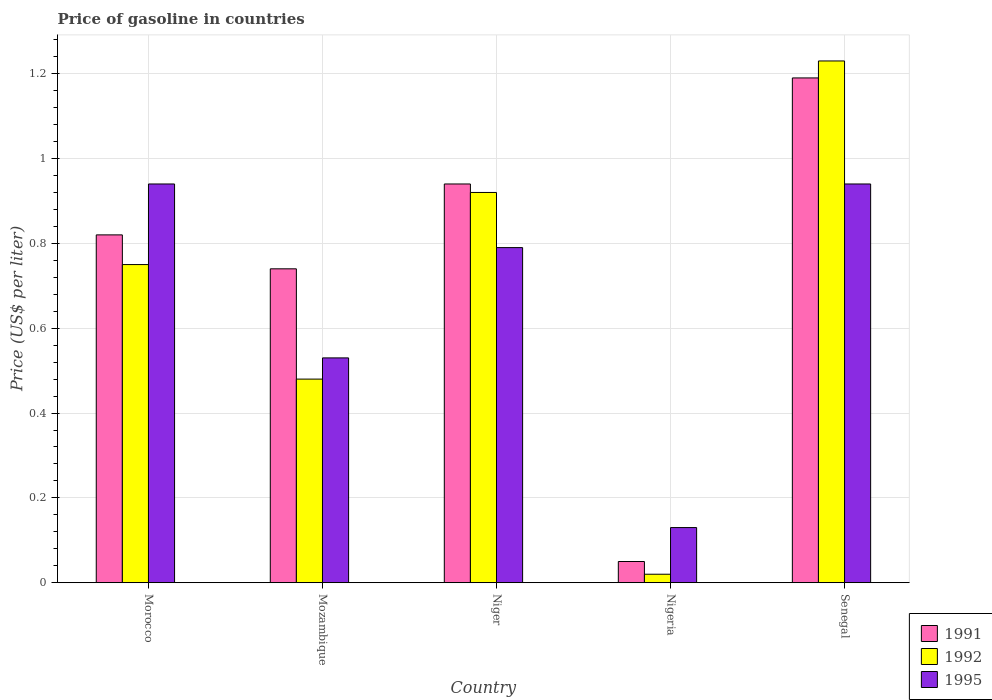How many groups of bars are there?
Offer a very short reply. 5. Are the number of bars on each tick of the X-axis equal?
Ensure brevity in your answer.  Yes. How many bars are there on the 1st tick from the left?
Offer a terse response. 3. What is the label of the 3rd group of bars from the left?
Your answer should be very brief. Niger. What is the price of gasoline in 1992 in Morocco?
Keep it short and to the point. 0.75. Across all countries, what is the maximum price of gasoline in 1995?
Provide a succinct answer. 0.94. Across all countries, what is the minimum price of gasoline in 1995?
Offer a terse response. 0.13. In which country was the price of gasoline in 1991 maximum?
Provide a succinct answer. Senegal. In which country was the price of gasoline in 1992 minimum?
Provide a short and direct response. Nigeria. What is the total price of gasoline in 1991 in the graph?
Give a very brief answer. 3.74. What is the difference between the price of gasoline in 1991 in Niger and the price of gasoline in 1995 in Mozambique?
Ensure brevity in your answer.  0.41. What is the average price of gasoline in 1995 per country?
Make the answer very short. 0.67. What is the difference between the price of gasoline of/in 1992 and price of gasoline of/in 1995 in Senegal?
Your answer should be very brief. 0.29. In how many countries, is the price of gasoline in 1991 greater than 0.12 US$?
Provide a short and direct response. 4. What is the ratio of the price of gasoline in 1995 in Niger to that in Nigeria?
Provide a succinct answer. 6.08. Is the price of gasoline in 1991 in Mozambique less than that in Senegal?
Give a very brief answer. Yes. What is the difference between the highest and the second highest price of gasoline in 1992?
Give a very brief answer. -0.31. What is the difference between the highest and the lowest price of gasoline in 1991?
Your answer should be very brief. 1.14. Is the sum of the price of gasoline in 1992 in Mozambique and Niger greater than the maximum price of gasoline in 1991 across all countries?
Your answer should be very brief. Yes. What does the 1st bar from the left in Mozambique represents?
Keep it short and to the point. 1991. What does the 3rd bar from the right in Niger represents?
Offer a terse response. 1991. Is it the case that in every country, the sum of the price of gasoline in 1991 and price of gasoline in 1995 is greater than the price of gasoline in 1992?
Keep it short and to the point. Yes. How many bars are there?
Your response must be concise. 15. Are all the bars in the graph horizontal?
Your answer should be very brief. No. How many countries are there in the graph?
Your response must be concise. 5. Does the graph contain any zero values?
Offer a very short reply. No. Does the graph contain grids?
Ensure brevity in your answer.  Yes. Where does the legend appear in the graph?
Your answer should be compact. Bottom right. How many legend labels are there?
Provide a succinct answer. 3. What is the title of the graph?
Offer a terse response. Price of gasoline in countries. Does "2012" appear as one of the legend labels in the graph?
Provide a short and direct response. No. What is the label or title of the Y-axis?
Make the answer very short. Price (US$ per liter). What is the Price (US$ per liter) of 1991 in Morocco?
Give a very brief answer. 0.82. What is the Price (US$ per liter) of 1991 in Mozambique?
Your response must be concise. 0.74. What is the Price (US$ per liter) in 1992 in Mozambique?
Make the answer very short. 0.48. What is the Price (US$ per liter) in 1995 in Mozambique?
Provide a short and direct response. 0.53. What is the Price (US$ per liter) of 1992 in Niger?
Provide a short and direct response. 0.92. What is the Price (US$ per liter) of 1995 in Niger?
Provide a short and direct response. 0.79. What is the Price (US$ per liter) of 1995 in Nigeria?
Provide a succinct answer. 0.13. What is the Price (US$ per liter) in 1991 in Senegal?
Provide a succinct answer. 1.19. What is the Price (US$ per liter) in 1992 in Senegal?
Offer a terse response. 1.23. What is the Price (US$ per liter) in 1995 in Senegal?
Your answer should be very brief. 0.94. Across all countries, what is the maximum Price (US$ per liter) of 1991?
Your answer should be compact. 1.19. Across all countries, what is the maximum Price (US$ per liter) in 1992?
Give a very brief answer. 1.23. Across all countries, what is the maximum Price (US$ per liter) of 1995?
Your answer should be compact. 0.94. Across all countries, what is the minimum Price (US$ per liter) in 1995?
Your answer should be compact. 0.13. What is the total Price (US$ per liter) in 1991 in the graph?
Your answer should be compact. 3.74. What is the total Price (US$ per liter) in 1992 in the graph?
Offer a terse response. 3.4. What is the total Price (US$ per liter) of 1995 in the graph?
Make the answer very short. 3.33. What is the difference between the Price (US$ per liter) in 1992 in Morocco and that in Mozambique?
Give a very brief answer. 0.27. What is the difference between the Price (US$ per liter) of 1995 in Morocco and that in Mozambique?
Ensure brevity in your answer.  0.41. What is the difference between the Price (US$ per liter) of 1991 in Morocco and that in Niger?
Provide a short and direct response. -0.12. What is the difference between the Price (US$ per liter) in 1992 in Morocco and that in Niger?
Offer a terse response. -0.17. What is the difference between the Price (US$ per liter) of 1991 in Morocco and that in Nigeria?
Provide a succinct answer. 0.77. What is the difference between the Price (US$ per liter) of 1992 in Morocco and that in Nigeria?
Make the answer very short. 0.73. What is the difference between the Price (US$ per liter) of 1995 in Morocco and that in Nigeria?
Provide a short and direct response. 0.81. What is the difference between the Price (US$ per liter) in 1991 in Morocco and that in Senegal?
Your response must be concise. -0.37. What is the difference between the Price (US$ per liter) of 1992 in Morocco and that in Senegal?
Your response must be concise. -0.48. What is the difference between the Price (US$ per liter) of 1992 in Mozambique and that in Niger?
Your response must be concise. -0.44. What is the difference between the Price (US$ per liter) in 1995 in Mozambique and that in Niger?
Ensure brevity in your answer.  -0.26. What is the difference between the Price (US$ per liter) in 1991 in Mozambique and that in Nigeria?
Provide a short and direct response. 0.69. What is the difference between the Price (US$ per liter) in 1992 in Mozambique and that in Nigeria?
Give a very brief answer. 0.46. What is the difference between the Price (US$ per liter) in 1995 in Mozambique and that in Nigeria?
Make the answer very short. 0.4. What is the difference between the Price (US$ per liter) in 1991 in Mozambique and that in Senegal?
Make the answer very short. -0.45. What is the difference between the Price (US$ per liter) of 1992 in Mozambique and that in Senegal?
Ensure brevity in your answer.  -0.75. What is the difference between the Price (US$ per liter) in 1995 in Mozambique and that in Senegal?
Give a very brief answer. -0.41. What is the difference between the Price (US$ per liter) of 1991 in Niger and that in Nigeria?
Your answer should be compact. 0.89. What is the difference between the Price (US$ per liter) in 1992 in Niger and that in Nigeria?
Give a very brief answer. 0.9. What is the difference between the Price (US$ per liter) of 1995 in Niger and that in Nigeria?
Offer a very short reply. 0.66. What is the difference between the Price (US$ per liter) in 1991 in Niger and that in Senegal?
Make the answer very short. -0.25. What is the difference between the Price (US$ per liter) of 1992 in Niger and that in Senegal?
Ensure brevity in your answer.  -0.31. What is the difference between the Price (US$ per liter) in 1991 in Nigeria and that in Senegal?
Your response must be concise. -1.14. What is the difference between the Price (US$ per liter) in 1992 in Nigeria and that in Senegal?
Offer a very short reply. -1.21. What is the difference between the Price (US$ per liter) in 1995 in Nigeria and that in Senegal?
Give a very brief answer. -0.81. What is the difference between the Price (US$ per liter) of 1991 in Morocco and the Price (US$ per liter) of 1992 in Mozambique?
Give a very brief answer. 0.34. What is the difference between the Price (US$ per liter) in 1991 in Morocco and the Price (US$ per liter) in 1995 in Mozambique?
Make the answer very short. 0.29. What is the difference between the Price (US$ per liter) of 1992 in Morocco and the Price (US$ per liter) of 1995 in Mozambique?
Keep it short and to the point. 0.22. What is the difference between the Price (US$ per liter) in 1991 in Morocco and the Price (US$ per liter) in 1992 in Niger?
Provide a succinct answer. -0.1. What is the difference between the Price (US$ per liter) in 1992 in Morocco and the Price (US$ per liter) in 1995 in Niger?
Provide a short and direct response. -0.04. What is the difference between the Price (US$ per liter) in 1991 in Morocco and the Price (US$ per liter) in 1992 in Nigeria?
Give a very brief answer. 0.8. What is the difference between the Price (US$ per liter) in 1991 in Morocco and the Price (US$ per liter) in 1995 in Nigeria?
Your answer should be very brief. 0.69. What is the difference between the Price (US$ per liter) of 1992 in Morocco and the Price (US$ per liter) of 1995 in Nigeria?
Give a very brief answer. 0.62. What is the difference between the Price (US$ per liter) of 1991 in Morocco and the Price (US$ per liter) of 1992 in Senegal?
Your answer should be compact. -0.41. What is the difference between the Price (US$ per liter) of 1991 in Morocco and the Price (US$ per liter) of 1995 in Senegal?
Provide a succinct answer. -0.12. What is the difference between the Price (US$ per liter) of 1992 in Morocco and the Price (US$ per liter) of 1995 in Senegal?
Offer a very short reply. -0.19. What is the difference between the Price (US$ per liter) of 1991 in Mozambique and the Price (US$ per liter) of 1992 in Niger?
Provide a short and direct response. -0.18. What is the difference between the Price (US$ per liter) of 1991 in Mozambique and the Price (US$ per liter) of 1995 in Niger?
Offer a terse response. -0.05. What is the difference between the Price (US$ per liter) of 1992 in Mozambique and the Price (US$ per liter) of 1995 in Niger?
Ensure brevity in your answer.  -0.31. What is the difference between the Price (US$ per liter) of 1991 in Mozambique and the Price (US$ per liter) of 1992 in Nigeria?
Your answer should be very brief. 0.72. What is the difference between the Price (US$ per liter) in 1991 in Mozambique and the Price (US$ per liter) in 1995 in Nigeria?
Your response must be concise. 0.61. What is the difference between the Price (US$ per liter) of 1992 in Mozambique and the Price (US$ per liter) of 1995 in Nigeria?
Your response must be concise. 0.35. What is the difference between the Price (US$ per liter) in 1991 in Mozambique and the Price (US$ per liter) in 1992 in Senegal?
Provide a short and direct response. -0.49. What is the difference between the Price (US$ per liter) of 1992 in Mozambique and the Price (US$ per liter) of 1995 in Senegal?
Give a very brief answer. -0.46. What is the difference between the Price (US$ per liter) of 1991 in Niger and the Price (US$ per liter) of 1992 in Nigeria?
Give a very brief answer. 0.92. What is the difference between the Price (US$ per liter) of 1991 in Niger and the Price (US$ per liter) of 1995 in Nigeria?
Your answer should be compact. 0.81. What is the difference between the Price (US$ per liter) in 1992 in Niger and the Price (US$ per liter) in 1995 in Nigeria?
Ensure brevity in your answer.  0.79. What is the difference between the Price (US$ per liter) of 1991 in Niger and the Price (US$ per liter) of 1992 in Senegal?
Ensure brevity in your answer.  -0.29. What is the difference between the Price (US$ per liter) of 1991 in Niger and the Price (US$ per liter) of 1995 in Senegal?
Ensure brevity in your answer.  0. What is the difference between the Price (US$ per liter) in 1992 in Niger and the Price (US$ per liter) in 1995 in Senegal?
Provide a short and direct response. -0.02. What is the difference between the Price (US$ per liter) of 1991 in Nigeria and the Price (US$ per liter) of 1992 in Senegal?
Offer a very short reply. -1.18. What is the difference between the Price (US$ per liter) of 1991 in Nigeria and the Price (US$ per liter) of 1995 in Senegal?
Your answer should be very brief. -0.89. What is the difference between the Price (US$ per liter) of 1992 in Nigeria and the Price (US$ per liter) of 1995 in Senegal?
Offer a terse response. -0.92. What is the average Price (US$ per liter) in 1991 per country?
Make the answer very short. 0.75. What is the average Price (US$ per liter) in 1992 per country?
Keep it short and to the point. 0.68. What is the average Price (US$ per liter) of 1995 per country?
Your response must be concise. 0.67. What is the difference between the Price (US$ per liter) of 1991 and Price (US$ per liter) of 1992 in Morocco?
Make the answer very short. 0.07. What is the difference between the Price (US$ per liter) in 1991 and Price (US$ per liter) in 1995 in Morocco?
Ensure brevity in your answer.  -0.12. What is the difference between the Price (US$ per liter) in 1992 and Price (US$ per liter) in 1995 in Morocco?
Ensure brevity in your answer.  -0.19. What is the difference between the Price (US$ per liter) of 1991 and Price (US$ per liter) of 1992 in Mozambique?
Make the answer very short. 0.26. What is the difference between the Price (US$ per liter) in 1991 and Price (US$ per liter) in 1995 in Mozambique?
Offer a terse response. 0.21. What is the difference between the Price (US$ per liter) in 1992 and Price (US$ per liter) in 1995 in Niger?
Provide a short and direct response. 0.13. What is the difference between the Price (US$ per liter) of 1991 and Price (US$ per liter) of 1992 in Nigeria?
Your answer should be compact. 0.03. What is the difference between the Price (US$ per liter) in 1991 and Price (US$ per liter) in 1995 in Nigeria?
Provide a short and direct response. -0.08. What is the difference between the Price (US$ per liter) of 1992 and Price (US$ per liter) of 1995 in Nigeria?
Offer a terse response. -0.11. What is the difference between the Price (US$ per liter) in 1991 and Price (US$ per liter) in 1992 in Senegal?
Make the answer very short. -0.04. What is the difference between the Price (US$ per liter) of 1992 and Price (US$ per liter) of 1995 in Senegal?
Offer a terse response. 0.29. What is the ratio of the Price (US$ per liter) of 1991 in Morocco to that in Mozambique?
Your response must be concise. 1.11. What is the ratio of the Price (US$ per liter) of 1992 in Morocco to that in Mozambique?
Ensure brevity in your answer.  1.56. What is the ratio of the Price (US$ per liter) of 1995 in Morocco to that in Mozambique?
Provide a succinct answer. 1.77. What is the ratio of the Price (US$ per liter) in 1991 in Morocco to that in Niger?
Your answer should be compact. 0.87. What is the ratio of the Price (US$ per liter) of 1992 in Morocco to that in Niger?
Ensure brevity in your answer.  0.82. What is the ratio of the Price (US$ per liter) of 1995 in Morocco to that in Niger?
Make the answer very short. 1.19. What is the ratio of the Price (US$ per liter) of 1991 in Morocco to that in Nigeria?
Ensure brevity in your answer.  16.4. What is the ratio of the Price (US$ per liter) in 1992 in Morocco to that in Nigeria?
Ensure brevity in your answer.  37.5. What is the ratio of the Price (US$ per liter) of 1995 in Morocco to that in Nigeria?
Provide a short and direct response. 7.23. What is the ratio of the Price (US$ per liter) in 1991 in Morocco to that in Senegal?
Ensure brevity in your answer.  0.69. What is the ratio of the Price (US$ per liter) of 1992 in Morocco to that in Senegal?
Your answer should be compact. 0.61. What is the ratio of the Price (US$ per liter) in 1991 in Mozambique to that in Niger?
Keep it short and to the point. 0.79. What is the ratio of the Price (US$ per liter) of 1992 in Mozambique to that in Niger?
Provide a short and direct response. 0.52. What is the ratio of the Price (US$ per liter) of 1995 in Mozambique to that in Niger?
Keep it short and to the point. 0.67. What is the ratio of the Price (US$ per liter) in 1991 in Mozambique to that in Nigeria?
Your answer should be compact. 14.8. What is the ratio of the Price (US$ per liter) in 1995 in Mozambique to that in Nigeria?
Ensure brevity in your answer.  4.08. What is the ratio of the Price (US$ per liter) in 1991 in Mozambique to that in Senegal?
Your answer should be very brief. 0.62. What is the ratio of the Price (US$ per liter) in 1992 in Mozambique to that in Senegal?
Ensure brevity in your answer.  0.39. What is the ratio of the Price (US$ per liter) in 1995 in Mozambique to that in Senegal?
Your answer should be compact. 0.56. What is the ratio of the Price (US$ per liter) in 1991 in Niger to that in Nigeria?
Give a very brief answer. 18.8. What is the ratio of the Price (US$ per liter) of 1992 in Niger to that in Nigeria?
Your answer should be very brief. 46. What is the ratio of the Price (US$ per liter) of 1995 in Niger to that in Nigeria?
Ensure brevity in your answer.  6.08. What is the ratio of the Price (US$ per liter) of 1991 in Niger to that in Senegal?
Provide a succinct answer. 0.79. What is the ratio of the Price (US$ per liter) in 1992 in Niger to that in Senegal?
Ensure brevity in your answer.  0.75. What is the ratio of the Price (US$ per liter) of 1995 in Niger to that in Senegal?
Make the answer very short. 0.84. What is the ratio of the Price (US$ per liter) in 1991 in Nigeria to that in Senegal?
Your answer should be very brief. 0.04. What is the ratio of the Price (US$ per liter) of 1992 in Nigeria to that in Senegal?
Keep it short and to the point. 0.02. What is the ratio of the Price (US$ per liter) in 1995 in Nigeria to that in Senegal?
Ensure brevity in your answer.  0.14. What is the difference between the highest and the second highest Price (US$ per liter) of 1992?
Provide a short and direct response. 0.31. What is the difference between the highest and the second highest Price (US$ per liter) of 1995?
Ensure brevity in your answer.  0. What is the difference between the highest and the lowest Price (US$ per liter) in 1991?
Provide a short and direct response. 1.14. What is the difference between the highest and the lowest Price (US$ per liter) in 1992?
Keep it short and to the point. 1.21. What is the difference between the highest and the lowest Price (US$ per liter) in 1995?
Your response must be concise. 0.81. 